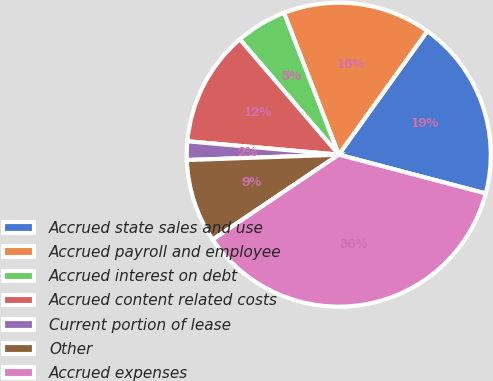Convert chart. <chart><loc_0><loc_0><loc_500><loc_500><pie_chart><fcel>Accrued state sales and use<fcel>Accrued payroll and employee<fcel>Accrued interest on debt<fcel>Accrued content related costs<fcel>Current portion of lease<fcel>Other<fcel>Accrued expenses<nl><fcel>19.21%<fcel>15.76%<fcel>5.42%<fcel>12.31%<fcel>1.97%<fcel>8.87%<fcel>36.46%<nl></chart> 